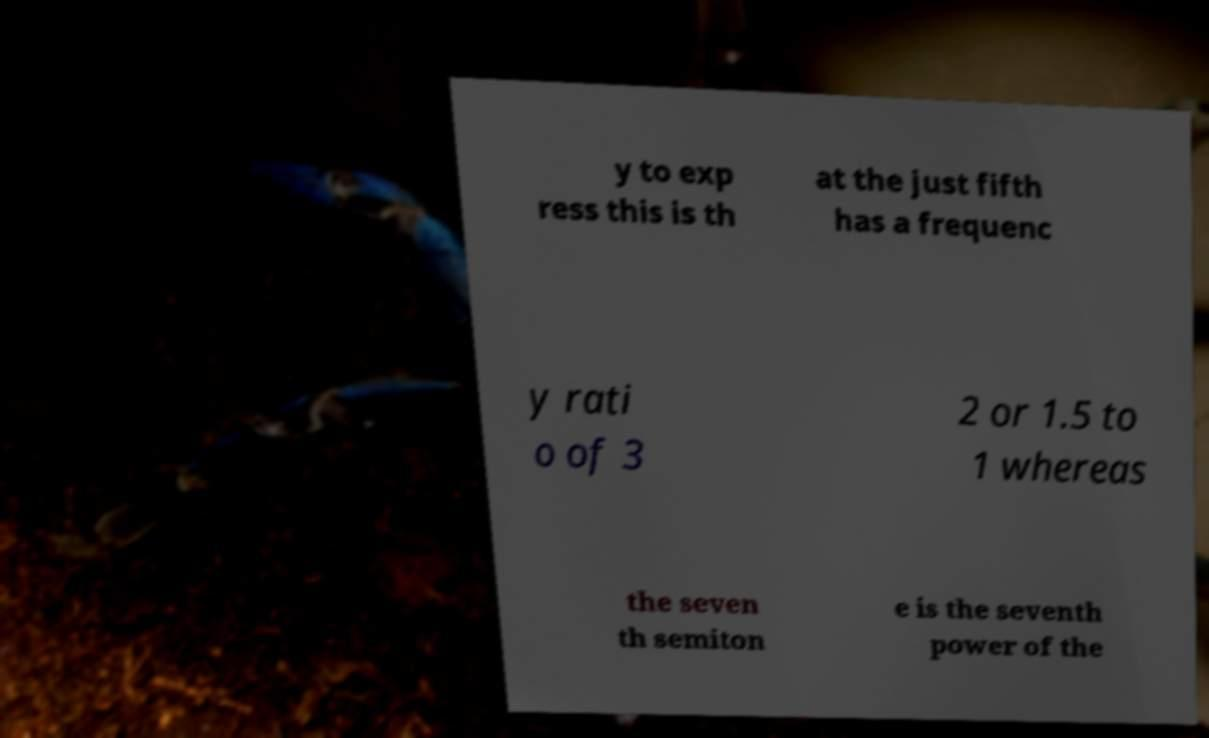What messages or text are displayed in this image? I need them in a readable, typed format. y to exp ress this is th at the just fifth has a frequenc y rati o of 3 2 or 1.5 to 1 whereas the seven th semiton e is the seventh power of the 